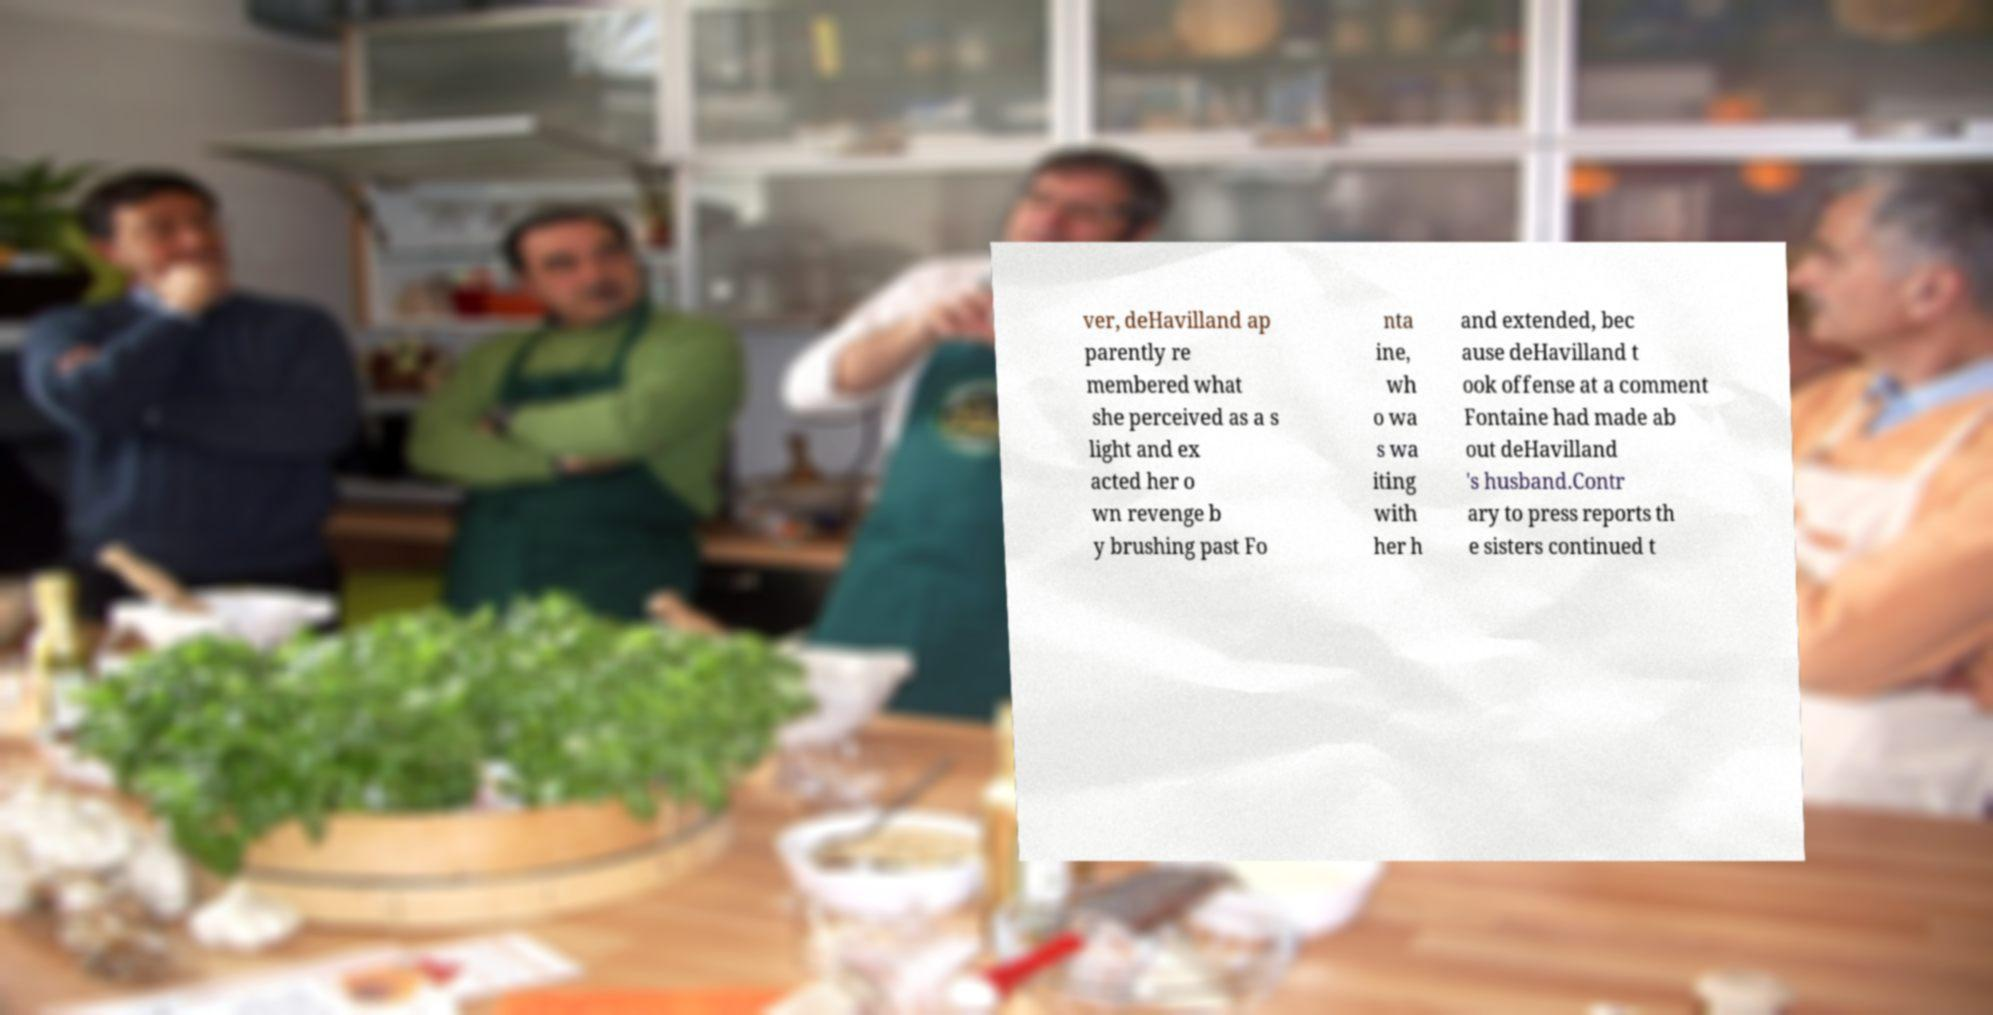For documentation purposes, I need the text within this image transcribed. Could you provide that? ver, deHavilland ap parently re membered what she perceived as a s light and ex acted her o wn revenge b y brushing past Fo nta ine, wh o wa s wa iting with her h and extended, bec ause deHavilland t ook offense at a comment Fontaine had made ab out deHavilland 's husband.Contr ary to press reports th e sisters continued t 